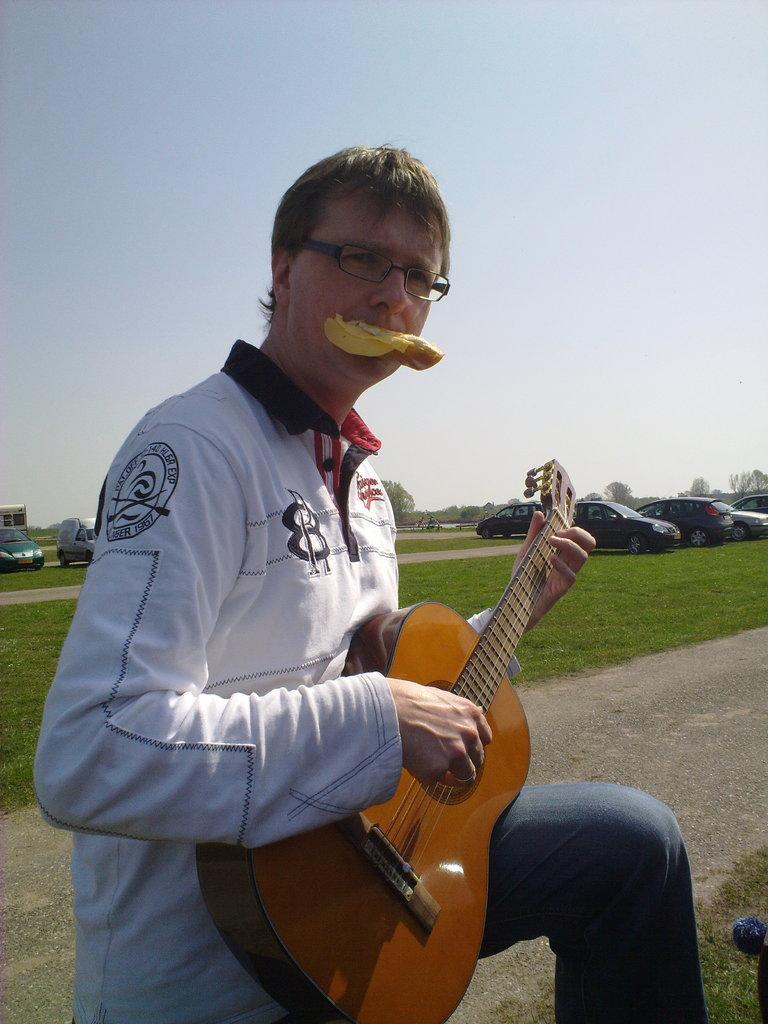Describe this image in one or two sentences. In this picture there is a man holding a guitar and in the backdrop the sky is clear 